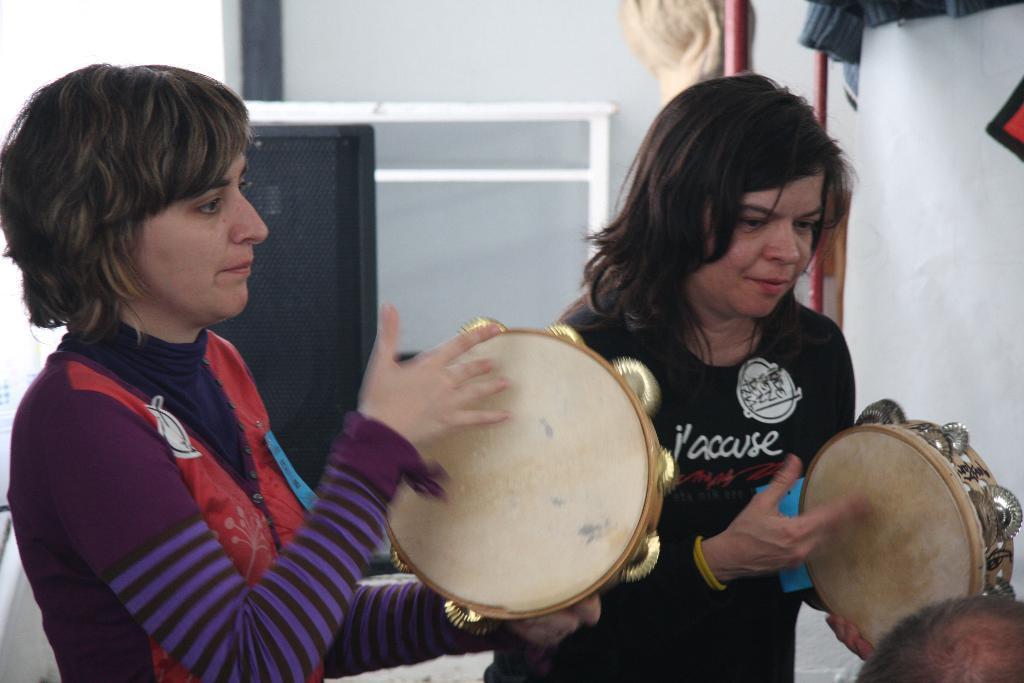Describe this image in one or two sentences. In the center of the image there are women playing musical instruments. In the background of the image there is wall. There is a speaker. 